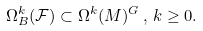Convert formula to latex. <formula><loc_0><loc_0><loc_500><loc_500>\Omega ^ { k } _ { B } ( { \mathcal { F } } ) \subset \Omega ^ { k } ( M ) ^ { G } \, , \, k \geq 0 .</formula> 